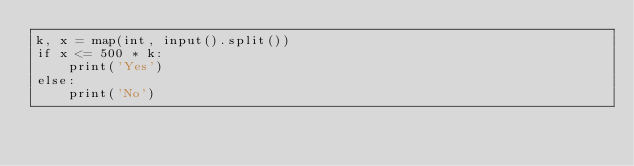<code> <loc_0><loc_0><loc_500><loc_500><_Python_>k, x = map(int, input().split())
if x <= 500 * k:
    print('Yes')
else:
    print('No')</code> 